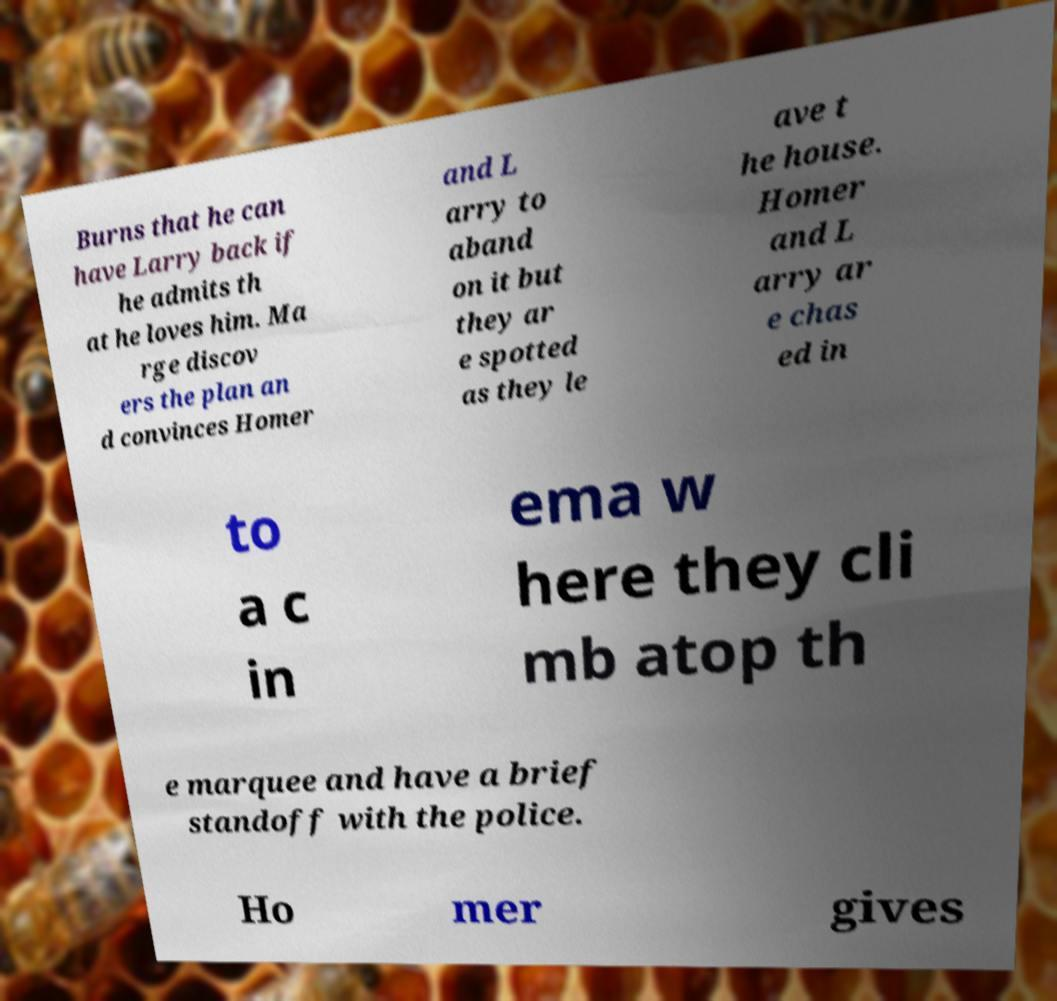I need the written content from this picture converted into text. Can you do that? Burns that he can have Larry back if he admits th at he loves him. Ma rge discov ers the plan an d convinces Homer and L arry to aband on it but they ar e spotted as they le ave t he house. Homer and L arry ar e chas ed in to a c in ema w here they cli mb atop th e marquee and have a brief standoff with the police. Ho mer gives 